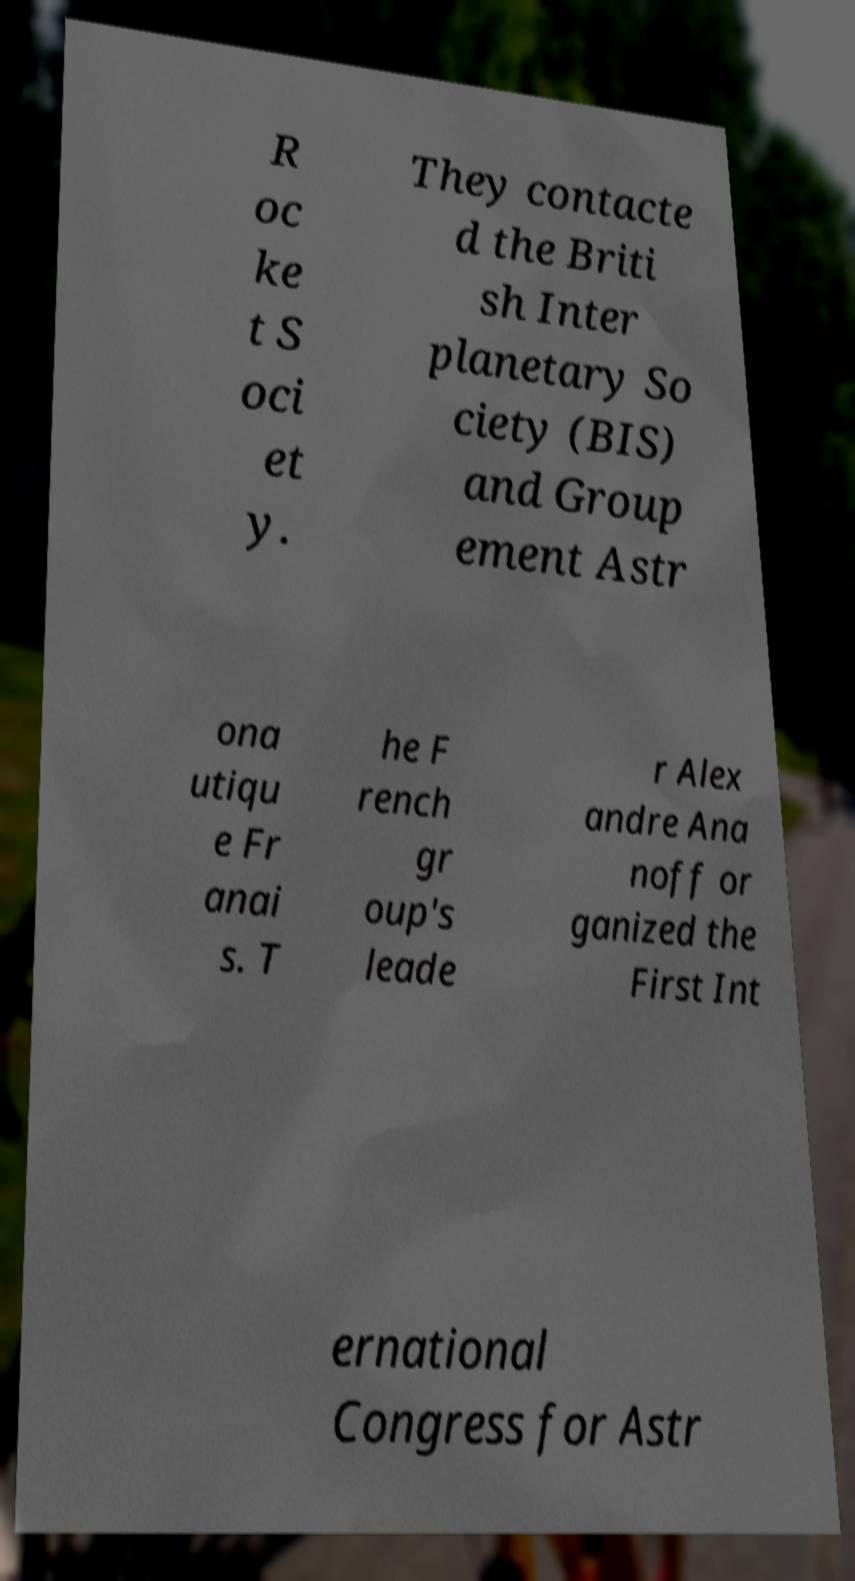What messages or text are displayed in this image? I need them in a readable, typed format. R oc ke t S oci et y. They contacte d the Briti sh Inter planetary So ciety (BIS) and Group ement Astr ona utiqu e Fr anai s. T he F rench gr oup's leade r Alex andre Ana noff or ganized the First Int ernational Congress for Astr 